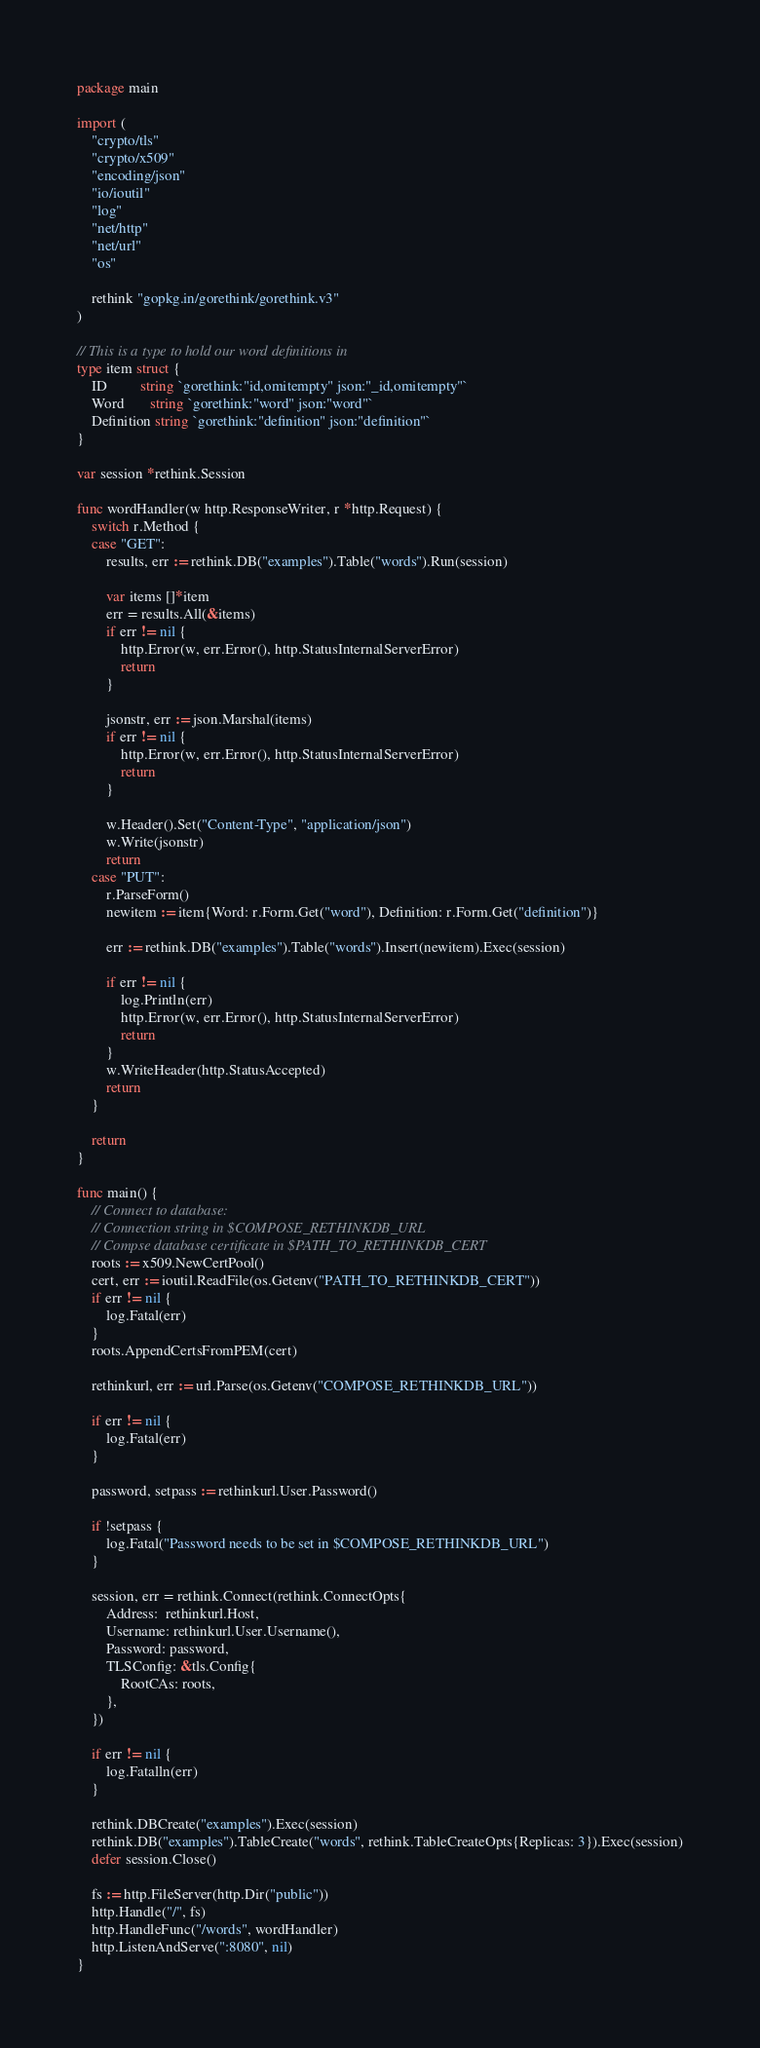<code> <loc_0><loc_0><loc_500><loc_500><_Go_>package main

import (
	"crypto/tls"
	"crypto/x509"
	"encoding/json"
	"io/ioutil"
	"log"
	"net/http"
	"net/url"
	"os"

	rethink "gopkg.in/gorethink/gorethink.v3"
)

// This is a type to hold our word definitions in
type item struct {
	ID         string `gorethink:"id,omitempty" json:"_id,omitempty"`
	Word       string `gorethink:"word" json:"word"`
	Definition string `gorethink:"definition" json:"definition"`
}

var session *rethink.Session

func wordHandler(w http.ResponseWriter, r *http.Request) {
	switch r.Method {
	case "GET":
		results, err := rethink.DB("examples").Table("words").Run(session)

		var items []*item
		err = results.All(&items)
		if err != nil {
			http.Error(w, err.Error(), http.StatusInternalServerError)
			return
		}

		jsonstr, err := json.Marshal(items)
		if err != nil {
			http.Error(w, err.Error(), http.StatusInternalServerError)
			return
		}

		w.Header().Set("Content-Type", "application/json")
		w.Write(jsonstr)
		return
	case "PUT":
		r.ParseForm()
		newitem := item{Word: r.Form.Get("word"), Definition: r.Form.Get("definition")}

		err := rethink.DB("examples").Table("words").Insert(newitem).Exec(session)

		if err != nil {
			log.Println(err)
			http.Error(w, err.Error(), http.StatusInternalServerError)
			return
		}
		w.WriteHeader(http.StatusAccepted)
		return
	}

	return
}

func main() {
	// Connect to database:
	// Connection string in $COMPOSE_RETHINKDB_URL
	// Compse database certificate in $PATH_TO_RETHINKDB_CERT
	roots := x509.NewCertPool()
	cert, err := ioutil.ReadFile(os.Getenv("PATH_TO_RETHINKDB_CERT"))
	if err != nil {
		log.Fatal(err)
	}
	roots.AppendCertsFromPEM(cert)

	rethinkurl, err := url.Parse(os.Getenv("COMPOSE_RETHINKDB_URL"))

	if err != nil {
		log.Fatal(err)
	}

	password, setpass := rethinkurl.User.Password()

	if !setpass {
		log.Fatal("Password needs to be set in $COMPOSE_RETHINKDB_URL")
	}

	session, err = rethink.Connect(rethink.ConnectOpts{
		Address:  rethinkurl.Host,
		Username: rethinkurl.User.Username(),
		Password: password,
		TLSConfig: &tls.Config{
			RootCAs: roots,
		},
	})

	if err != nil {
		log.Fatalln(err)
	}

	rethink.DBCreate("examples").Exec(session)
	rethink.DB("examples").TableCreate("words", rethink.TableCreateOpts{Replicas: 3}).Exec(session)
	defer session.Close()

	fs := http.FileServer(http.Dir("public"))
	http.Handle("/", fs)
	http.HandleFunc("/words", wordHandler)
	http.ListenAndServe(":8080", nil)
}
</code> 